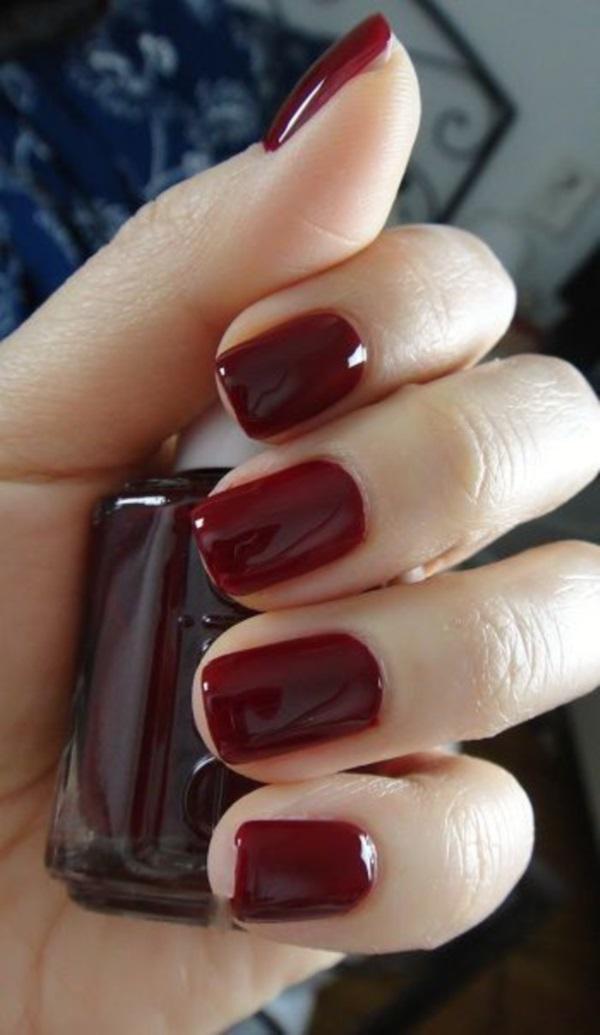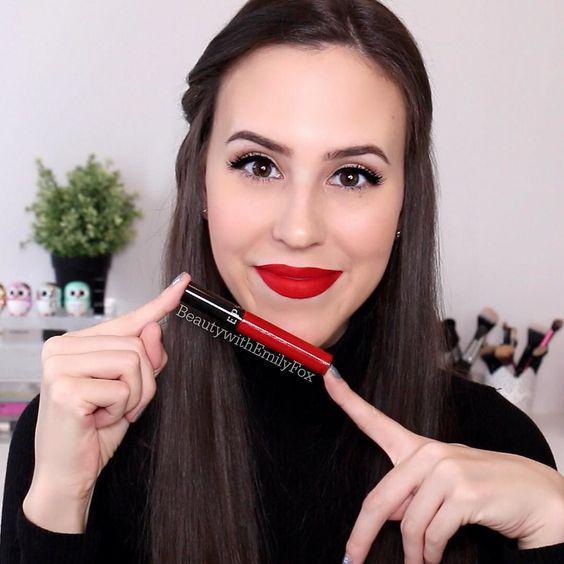The first image is the image on the left, the second image is the image on the right. Considering the images on both sides, is "There is a woman wearing lipstick on the right image and swatches of lip products on the left." valid? Answer yes or no. No. The first image is the image on the left, the second image is the image on the right. Assess this claim about the two images: "One image includes multiple deep-red painted fingernails, and at least one image includes tinted lips.". Correct or not? Answer yes or no. Yes. 